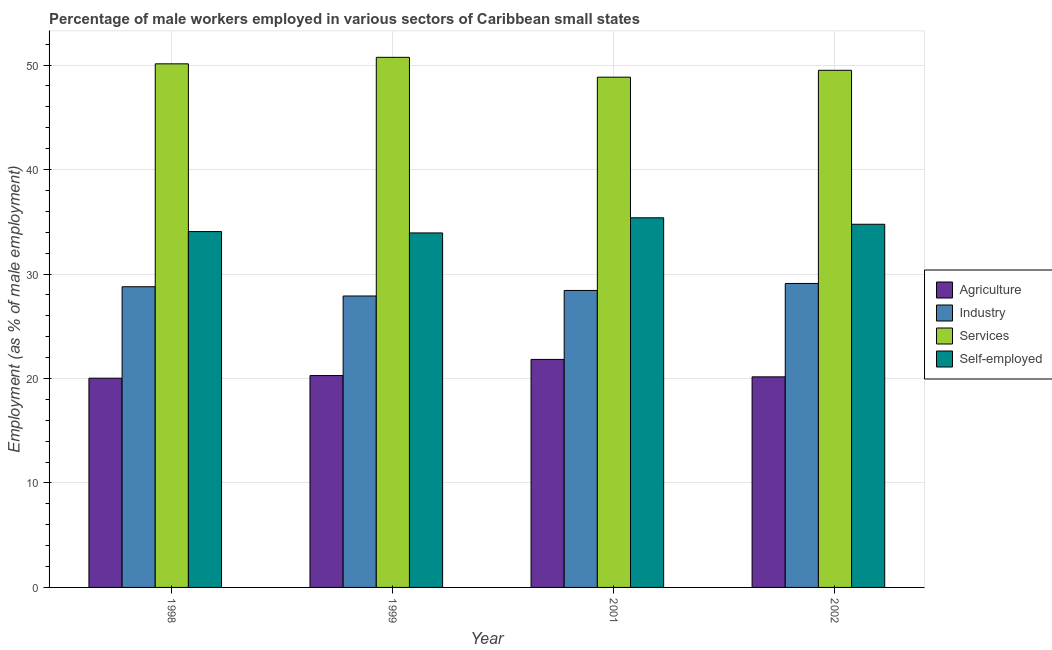How many groups of bars are there?
Provide a succinct answer. 4. Are the number of bars per tick equal to the number of legend labels?
Offer a very short reply. Yes. Are the number of bars on each tick of the X-axis equal?
Offer a very short reply. Yes. What is the label of the 4th group of bars from the left?
Provide a short and direct response. 2002. What is the percentage of male workers in services in 1998?
Your response must be concise. 50.12. Across all years, what is the maximum percentage of male workers in industry?
Provide a short and direct response. 29.09. Across all years, what is the minimum percentage of male workers in agriculture?
Offer a very short reply. 20.03. In which year was the percentage of male workers in agriculture minimum?
Your answer should be compact. 1998. What is the total percentage of male workers in services in the graph?
Ensure brevity in your answer.  199.19. What is the difference between the percentage of male workers in industry in 1999 and that in 2002?
Keep it short and to the point. -1.2. What is the difference between the percentage of male workers in industry in 2001 and the percentage of male workers in services in 2002?
Provide a succinct answer. -0.67. What is the average percentage of male workers in industry per year?
Offer a terse response. 28.55. In the year 2002, what is the difference between the percentage of male workers in agriculture and percentage of self employed male workers?
Your response must be concise. 0. What is the ratio of the percentage of male workers in industry in 1999 to that in 2002?
Your answer should be very brief. 0.96. Is the percentage of male workers in services in 1998 less than that in 2002?
Provide a short and direct response. No. What is the difference between the highest and the second highest percentage of male workers in services?
Make the answer very short. 0.62. What is the difference between the highest and the lowest percentage of male workers in industry?
Offer a terse response. 1.2. Is it the case that in every year, the sum of the percentage of self employed male workers and percentage of male workers in services is greater than the sum of percentage of male workers in agriculture and percentage of male workers in industry?
Provide a short and direct response. Yes. What does the 2nd bar from the left in 1998 represents?
Your answer should be compact. Industry. What does the 1st bar from the right in 1998 represents?
Provide a short and direct response. Self-employed. How many years are there in the graph?
Provide a succinct answer. 4. Are the values on the major ticks of Y-axis written in scientific E-notation?
Make the answer very short. No. Does the graph contain grids?
Make the answer very short. Yes. How are the legend labels stacked?
Your answer should be very brief. Vertical. What is the title of the graph?
Provide a short and direct response. Percentage of male workers employed in various sectors of Caribbean small states. What is the label or title of the Y-axis?
Your answer should be compact. Employment (as % of male employment). What is the Employment (as % of male employment) of Agriculture in 1998?
Your response must be concise. 20.03. What is the Employment (as % of male employment) of Industry in 1998?
Make the answer very short. 28.78. What is the Employment (as % of male employment) of Services in 1998?
Keep it short and to the point. 50.12. What is the Employment (as % of male employment) of Self-employed in 1998?
Give a very brief answer. 34.06. What is the Employment (as % of male employment) of Agriculture in 1999?
Give a very brief answer. 20.28. What is the Employment (as % of male employment) in Industry in 1999?
Offer a terse response. 27.89. What is the Employment (as % of male employment) of Services in 1999?
Offer a terse response. 50.74. What is the Employment (as % of male employment) in Self-employed in 1999?
Offer a terse response. 33.93. What is the Employment (as % of male employment) in Agriculture in 2001?
Make the answer very short. 21.82. What is the Employment (as % of male employment) of Industry in 2001?
Your response must be concise. 28.43. What is the Employment (as % of male employment) in Services in 2001?
Make the answer very short. 48.84. What is the Employment (as % of male employment) in Self-employed in 2001?
Offer a very short reply. 35.38. What is the Employment (as % of male employment) of Agriculture in 2002?
Ensure brevity in your answer.  20.16. What is the Employment (as % of male employment) of Industry in 2002?
Offer a terse response. 29.09. What is the Employment (as % of male employment) of Services in 2002?
Offer a terse response. 49.5. What is the Employment (as % of male employment) in Self-employed in 2002?
Make the answer very short. 34.76. Across all years, what is the maximum Employment (as % of male employment) of Agriculture?
Offer a very short reply. 21.82. Across all years, what is the maximum Employment (as % of male employment) in Industry?
Offer a very short reply. 29.09. Across all years, what is the maximum Employment (as % of male employment) in Services?
Offer a terse response. 50.74. Across all years, what is the maximum Employment (as % of male employment) of Self-employed?
Ensure brevity in your answer.  35.38. Across all years, what is the minimum Employment (as % of male employment) in Agriculture?
Your answer should be compact. 20.03. Across all years, what is the minimum Employment (as % of male employment) of Industry?
Your response must be concise. 27.89. Across all years, what is the minimum Employment (as % of male employment) of Services?
Offer a terse response. 48.84. Across all years, what is the minimum Employment (as % of male employment) in Self-employed?
Your answer should be compact. 33.93. What is the total Employment (as % of male employment) in Agriculture in the graph?
Make the answer very short. 82.29. What is the total Employment (as % of male employment) in Industry in the graph?
Your answer should be very brief. 114.19. What is the total Employment (as % of male employment) of Services in the graph?
Your response must be concise. 199.19. What is the total Employment (as % of male employment) in Self-employed in the graph?
Ensure brevity in your answer.  138.13. What is the difference between the Employment (as % of male employment) of Agriculture in 1998 and that in 1999?
Offer a very short reply. -0.25. What is the difference between the Employment (as % of male employment) in Industry in 1998 and that in 1999?
Give a very brief answer. 0.89. What is the difference between the Employment (as % of male employment) in Services in 1998 and that in 1999?
Offer a terse response. -0.62. What is the difference between the Employment (as % of male employment) of Self-employed in 1998 and that in 1999?
Provide a short and direct response. 0.13. What is the difference between the Employment (as % of male employment) of Agriculture in 1998 and that in 2001?
Your answer should be very brief. -1.8. What is the difference between the Employment (as % of male employment) of Industry in 1998 and that in 2001?
Your answer should be very brief. 0.35. What is the difference between the Employment (as % of male employment) in Services in 1998 and that in 2001?
Give a very brief answer. 1.28. What is the difference between the Employment (as % of male employment) in Self-employed in 1998 and that in 2001?
Make the answer very short. -1.32. What is the difference between the Employment (as % of male employment) in Agriculture in 1998 and that in 2002?
Your response must be concise. -0.13. What is the difference between the Employment (as % of male employment) of Industry in 1998 and that in 2002?
Provide a short and direct response. -0.31. What is the difference between the Employment (as % of male employment) of Services in 1998 and that in 2002?
Keep it short and to the point. 0.62. What is the difference between the Employment (as % of male employment) of Self-employed in 1998 and that in 2002?
Offer a terse response. -0.7. What is the difference between the Employment (as % of male employment) in Agriculture in 1999 and that in 2001?
Offer a terse response. -1.55. What is the difference between the Employment (as % of male employment) in Industry in 1999 and that in 2001?
Provide a succinct answer. -0.53. What is the difference between the Employment (as % of male employment) in Services in 1999 and that in 2001?
Your response must be concise. 1.9. What is the difference between the Employment (as % of male employment) in Self-employed in 1999 and that in 2001?
Offer a terse response. -1.45. What is the difference between the Employment (as % of male employment) in Agriculture in 1999 and that in 2002?
Your answer should be compact. 0.12. What is the difference between the Employment (as % of male employment) in Industry in 1999 and that in 2002?
Give a very brief answer. -1.2. What is the difference between the Employment (as % of male employment) of Services in 1999 and that in 2002?
Offer a terse response. 1.24. What is the difference between the Employment (as % of male employment) in Self-employed in 1999 and that in 2002?
Provide a short and direct response. -0.83. What is the difference between the Employment (as % of male employment) of Agriculture in 2001 and that in 2002?
Your answer should be compact. 1.67. What is the difference between the Employment (as % of male employment) in Industry in 2001 and that in 2002?
Offer a terse response. -0.67. What is the difference between the Employment (as % of male employment) of Services in 2001 and that in 2002?
Your answer should be compact. -0.66. What is the difference between the Employment (as % of male employment) in Self-employed in 2001 and that in 2002?
Your answer should be very brief. 0.62. What is the difference between the Employment (as % of male employment) in Agriculture in 1998 and the Employment (as % of male employment) in Industry in 1999?
Offer a very short reply. -7.87. What is the difference between the Employment (as % of male employment) of Agriculture in 1998 and the Employment (as % of male employment) of Services in 1999?
Provide a succinct answer. -30.71. What is the difference between the Employment (as % of male employment) of Agriculture in 1998 and the Employment (as % of male employment) of Self-employed in 1999?
Provide a succinct answer. -13.9. What is the difference between the Employment (as % of male employment) of Industry in 1998 and the Employment (as % of male employment) of Services in 1999?
Provide a succinct answer. -21.96. What is the difference between the Employment (as % of male employment) of Industry in 1998 and the Employment (as % of male employment) of Self-employed in 1999?
Your answer should be compact. -5.15. What is the difference between the Employment (as % of male employment) in Services in 1998 and the Employment (as % of male employment) in Self-employed in 1999?
Provide a short and direct response. 16.19. What is the difference between the Employment (as % of male employment) of Agriculture in 1998 and the Employment (as % of male employment) of Industry in 2001?
Your response must be concise. -8.4. What is the difference between the Employment (as % of male employment) in Agriculture in 1998 and the Employment (as % of male employment) in Services in 2001?
Offer a very short reply. -28.81. What is the difference between the Employment (as % of male employment) in Agriculture in 1998 and the Employment (as % of male employment) in Self-employed in 2001?
Provide a short and direct response. -15.35. What is the difference between the Employment (as % of male employment) in Industry in 1998 and the Employment (as % of male employment) in Services in 2001?
Offer a terse response. -20.06. What is the difference between the Employment (as % of male employment) of Industry in 1998 and the Employment (as % of male employment) of Self-employed in 2001?
Give a very brief answer. -6.6. What is the difference between the Employment (as % of male employment) in Services in 1998 and the Employment (as % of male employment) in Self-employed in 2001?
Keep it short and to the point. 14.74. What is the difference between the Employment (as % of male employment) in Agriculture in 1998 and the Employment (as % of male employment) in Industry in 2002?
Your response must be concise. -9.06. What is the difference between the Employment (as % of male employment) of Agriculture in 1998 and the Employment (as % of male employment) of Services in 2002?
Ensure brevity in your answer.  -29.47. What is the difference between the Employment (as % of male employment) in Agriculture in 1998 and the Employment (as % of male employment) in Self-employed in 2002?
Your answer should be very brief. -14.73. What is the difference between the Employment (as % of male employment) of Industry in 1998 and the Employment (as % of male employment) of Services in 2002?
Provide a succinct answer. -20.72. What is the difference between the Employment (as % of male employment) in Industry in 1998 and the Employment (as % of male employment) in Self-employed in 2002?
Provide a succinct answer. -5.98. What is the difference between the Employment (as % of male employment) in Services in 1998 and the Employment (as % of male employment) in Self-employed in 2002?
Ensure brevity in your answer.  15.35. What is the difference between the Employment (as % of male employment) in Agriculture in 1999 and the Employment (as % of male employment) in Industry in 2001?
Your response must be concise. -8.15. What is the difference between the Employment (as % of male employment) in Agriculture in 1999 and the Employment (as % of male employment) in Services in 2001?
Make the answer very short. -28.56. What is the difference between the Employment (as % of male employment) in Agriculture in 1999 and the Employment (as % of male employment) in Self-employed in 2001?
Provide a succinct answer. -15.1. What is the difference between the Employment (as % of male employment) in Industry in 1999 and the Employment (as % of male employment) in Services in 2001?
Provide a succinct answer. -20.94. What is the difference between the Employment (as % of male employment) in Industry in 1999 and the Employment (as % of male employment) in Self-employed in 2001?
Give a very brief answer. -7.49. What is the difference between the Employment (as % of male employment) in Services in 1999 and the Employment (as % of male employment) in Self-employed in 2001?
Provide a succinct answer. 15.36. What is the difference between the Employment (as % of male employment) in Agriculture in 1999 and the Employment (as % of male employment) in Industry in 2002?
Give a very brief answer. -8.81. What is the difference between the Employment (as % of male employment) in Agriculture in 1999 and the Employment (as % of male employment) in Services in 2002?
Make the answer very short. -29.22. What is the difference between the Employment (as % of male employment) of Agriculture in 1999 and the Employment (as % of male employment) of Self-employed in 2002?
Provide a short and direct response. -14.48. What is the difference between the Employment (as % of male employment) in Industry in 1999 and the Employment (as % of male employment) in Services in 2002?
Offer a very short reply. -21.6. What is the difference between the Employment (as % of male employment) of Industry in 1999 and the Employment (as % of male employment) of Self-employed in 2002?
Your answer should be compact. -6.87. What is the difference between the Employment (as % of male employment) of Services in 1999 and the Employment (as % of male employment) of Self-employed in 2002?
Give a very brief answer. 15.98. What is the difference between the Employment (as % of male employment) in Agriculture in 2001 and the Employment (as % of male employment) in Industry in 2002?
Keep it short and to the point. -7.27. What is the difference between the Employment (as % of male employment) in Agriculture in 2001 and the Employment (as % of male employment) in Services in 2002?
Your response must be concise. -27.67. What is the difference between the Employment (as % of male employment) of Agriculture in 2001 and the Employment (as % of male employment) of Self-employed in 2002?
Give a very brief answer. -12.94. What is the difference between the Employment (as % of male employment) of Industry in 2001 and the Employment (as % of male employment) of Services in 2002?
Provide a short and direct response. -21.07. What is the difference between the Employment (as % of male employment) of Industry in 2001 and the Employment (as % of male employment) of Self-employed in 2002?
Provide a succinct answer. -6.34. What is the difference between the Employment (as % of male employment) in Services in 2001 and the Employment (as % of male employment) in Self-employed in 2002?
Keep it short and to the point. 14.08. What is the average Employment (as % of male employment) in Agriculture per year?
Make the answer very short. 20.57. What is the average Employment (as % of male employment) in Industry per year?
Ensure brevity in your answer.  28.55. What is the average Employment (as % of male employment) of Services per year?
Keep it short and to the point. 49.8. What is the average Employment (as % of male employment) of Self-employed per year?
Your answer should be compact. 34.53. In the year 1998, what is the difference between the Employment (as % of male employment) of Agriculture and Employment (as % of male employment) of Industry?
Keep it short and to the point. -8.75. In the year 1998, what is the difference between the Employment (as % of male employment) of Agriculture and Employment (as % of male employment) of Services?
Keep it short and to the point. -30.09. In the year 1998, what is the difference between the Employment (as % of male employment) in Agriculture and Employment (as % of male employment) in Self-employed?
Offer a very short reply. -14.03. In the year 1998, what is the difference between the Employment (as % of male employment) of Industry and Employment (as % of male employment) of Services?
Your answer should be very brief. -21.34. In the year 1998, what is the difference between the Employment (as % of male employment) in Industry and Employment (as % of male employment) in Self-employed?
Your answer should be compact. -5.28. In the year 1998, what is the difference between the Employment (as % of male employment) of Services and Employment (as % of male employment) of Self-employed?
Keep it short and to the point. 16.06. In the year 1999, what is the difference between the Employment (as % of male employment) in Agriculture and Employment (as % of male employment) in Industry?
Keep it short and to the point. -7.62. In the year 1999, what is the difference between the Employment (as % of male employment) in Agriculture and Employment (as % of male employment) in Services?
Your response must be concise. -30.46. In the year 1999, what is the difference between the Employment (as % of male employment) of Agriculture and Employment (as % of male employment) of Self-employed?
Ensure brevity in your answer.  -13.65. In the year 1999, what is the difference between the Employment (as % of male employment) in Industry and Employment (as % of male employment) in Services?
Your answer should be very brief. -22.84. In the year 1999, what is the difference between the Employment (as % of male employment) of Industry and Employment (as % of male employment) of Self-employed?
Provide a short and direct response. -6.04. In the year 1999, what is the difference between the Employment (as % of male employment) in Services and Employment (as % of male employment) in Self-employed?
Offer a very short reply. 16.81. In the year 2001, what is the difference between the Employment (as % of male employment) of Agriculture and Employment (as % of male employment) of Industry?
Make the answer very short. -6.6. In the year 2001, what is the difference between the Employment (as % of male employment) in Agriculture and Employment (as % of male employment) in Services?
Make the answer very short. -27.01. In the year 2001, what is the difference between the Employment (as % of male employment) in Agriculture and Employment (as % of male employment) in Self-employed?
Make the answer very short. -13.56. In the year 2001, what is the difference between the Employment (as % of male employment) of Industry and Employment (as % of male employment) of Services?
Your answer should be compact. -20.41. In the year 2001, what is the difference between the Employment (as % of male employment) in Industry and Employment (as % of male employment) in Self-employed?
Provide a short and direct response. -6.95. In the year 2001, what is the difference between the Employment (as % of male employment) of Services and Employment (as % of male employment) of Self-employed?
Make the answer very short. 13.46. In the year 2002, what is the difference between the Employment (as % of male employment) of Agriculture and Employment (as % of male employment) of Industry?
Offer a very short reply. -8.94. In the year 2002, what is the difference between the Employment (as % of male employment) of Agriculture and Employment (as % of male employment) of Services?
Provide a short and direct response. -29.34. In the year 2002, what is the difference between the Employment (as % of male employment) of Agriculture and Employment (as % of male employment) of Self-employed?
Offer a very short reply. -14.61. In the year 2002, what is the difference between the Employment (as % of male employment) of Industry and Employment (as % of male employment) of Services?
Make the answer very short. -20.4. In the year 2002, what is the difference between the Employment (as % of male employment) of Industry and Employment (as % of male employment) of Self-employed?
Give a very brief answer. -5.67. In the year 2002, what is the difference between the Employment (as % of male employment) in Services and Employment (as % of male employment) in Self-employed?
Keep it short and to the point. 14.74. What is the ratio of the Employment (as % of male employment) in Agriculture in 1998 to that in 1999?
Give a very brief answer. 0.99. What is the ratio of the Employment (as % of male employment) in Industry in 1998 to that in 1999?
Offer a terse response. 1.03. What is the ratio of the Employment (as % of male employment) in Services in 1998 to that in 1999?
Keep it short and to the point. 0.99. What is the ratio of the Employment (as % of male employment) in Agriculture in 1998 to that in 2001?
Keep it short and to the point. 0.92. What is the ratio of the Employment (as % of male employment) of Industry in 1998 to that in 2001?
Keep it short and to the point. 1.01. What is the ratio of the Employment (as % of male employment) in Services in 1998 to that in 2001?
Ensure brevity in your answer.  1.03. What is the ratio of the Employment (as % of male employment) in Self-employed in 1998 to that in 2001?
Keep it short and to the point. 0.96. What is the ratio of the Employment (as % of male employment) in Agriculture in 1998 to that in 2002?
Offer a terse response. 0.99. What is the ratio of the Employment (as % of male employment) of Industry in 1998 to that in 2002?
Keep it short and to the point. 0.99. What is the ratio of the Employment (as % of male employment) in Services in 1998 to that in 2002?
Your answer should be very brief. 1.01. What is the ratio of the Employment (as % of male employment) of Self-employed in 1998 to that in 2002?
Your answer should be very brief. 0.98. What is the ratio of the Employment (as % of male employment) of Agriculture in 1999 to that in 2001?
Provide a succinct answer. 0.93. What is the ratio of the Employment (as % of male employment) in Industry in 1999 to that in 2001?
Provide a succinct answer. 0.98. What is the ratio of the Employment (as % of male employment) in Services in 1999 to that in 2001?
Ensure brevity in your answer.  1.04. What is the ratio of the Employment (as % of male employment) in Self-employed in 1999 to that in 2001?
Your answer should be very brief. 0.96. What is the ratio of the Employment (as % of male employment) in Industry in 1999 to that in 2002?
Your answer should be very brief. 0.96. What is the ratio of the Employment (as % of male employment) of Services in 1999 to that in 2002?
Provide a succinct answer. 1.03. What is the ratio of the Employment (as % of male employment) of Self-employed in 1999 to that in 2002?
Offer a terse response. 0.98. What is the ratio of the Employment (as % of male employment) in Agriculture in 2001 to that in 2002?
Keep it short and to the point. 1.08. What is the ratio of the Employment (as % of male employment) of Industry in 2001 to that in 2002?
Offer a very short reply. 0.98. What is the ratio of the Employment (as % of male employment) of Services in 2001 to that in 2002?
Make the answer very short. 0.99. What is the ratio of the Employment (as % of male employment) of Self-employed in 2001 to that in 2002?
Ensure brevity in your answer.  1.02. What is the difference between the highest and the second highest Employment (as % of male employment) in Agriculture?
Offer a very short reply. 1.55. What is the difference between the highest and the second highest Employment (as % of male employment) in Industry?
Your answer should be compact. 0.31. What is the difference between the highest and the second highest Employment (as % of male employment) of Services?
Keep it short and to the point. 0.62. What is the difference between the highest and the second highest Employment (as % of male employment) of Self-employed?
Your response must be concise. 0.62. What is the difference between the highest and the lowest Employment (as % of male employment) in Agriculture?
Offer a terse response. 1.8. What is the difference between the highest and the lowest Employment (as % of male employment) of Industry?
Offer a terse response. 1.2. What is the difference between the highest and the lowest Employment (as % of male employment) of Services?
Give a very brief answer. 1.9. What is the difference between the highest and the lowest Employment (as % of male employment) in Self-employed?
Keep it short and to the point. 1.45. 